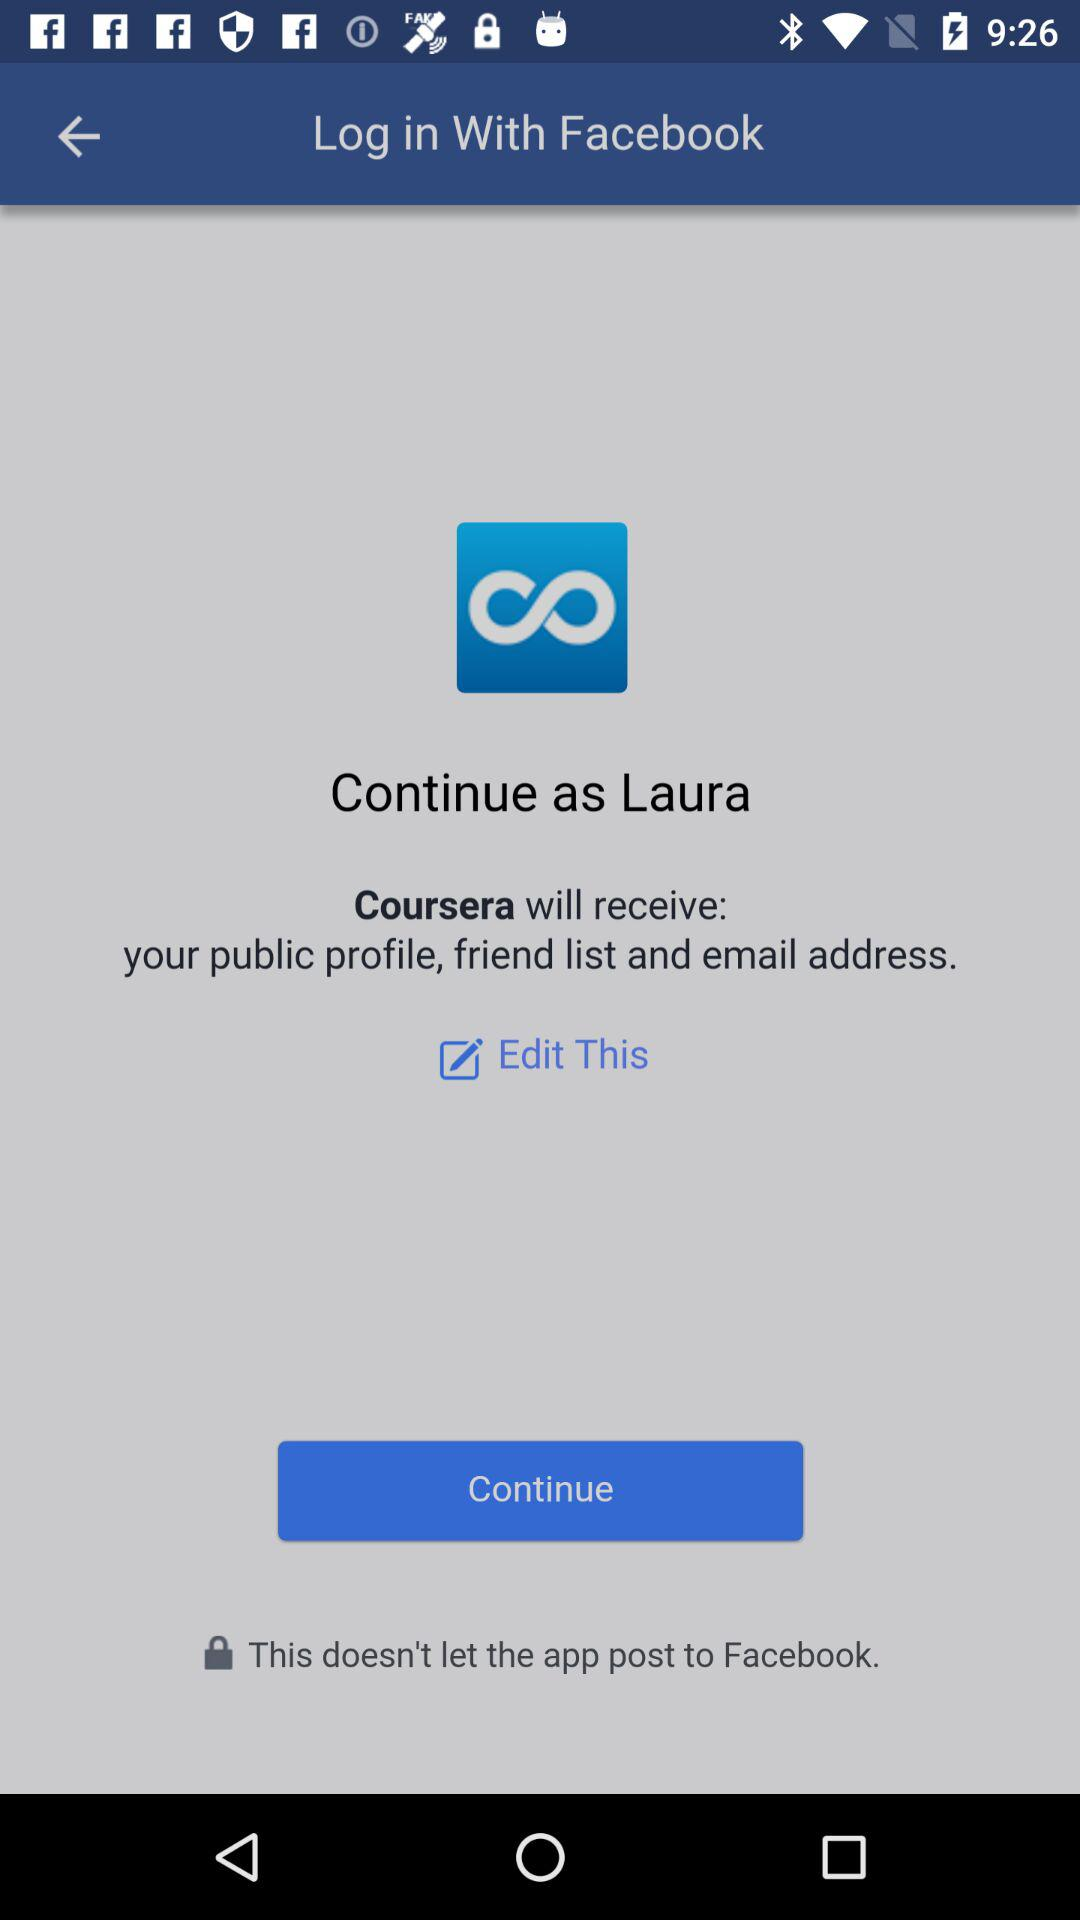Through what application can a user log in with? You can login with "Facebook". 